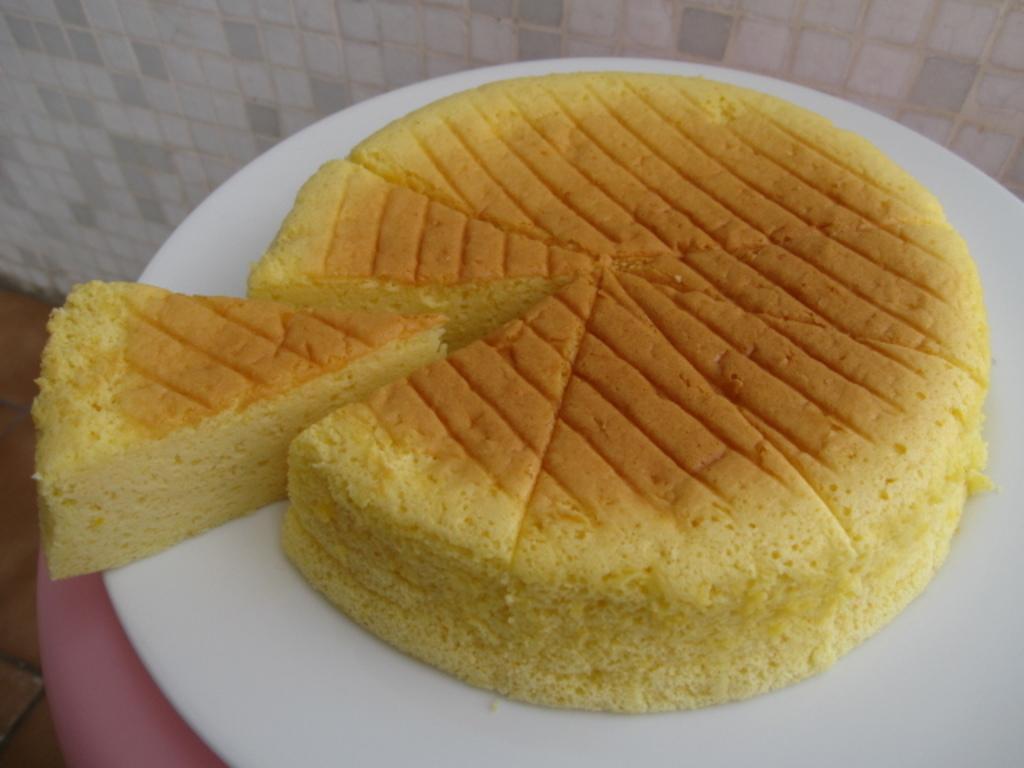In one or two sentences, can you explain what this image depicts? In this image there is a marble wall on the backside. There is a cake on the plate. 